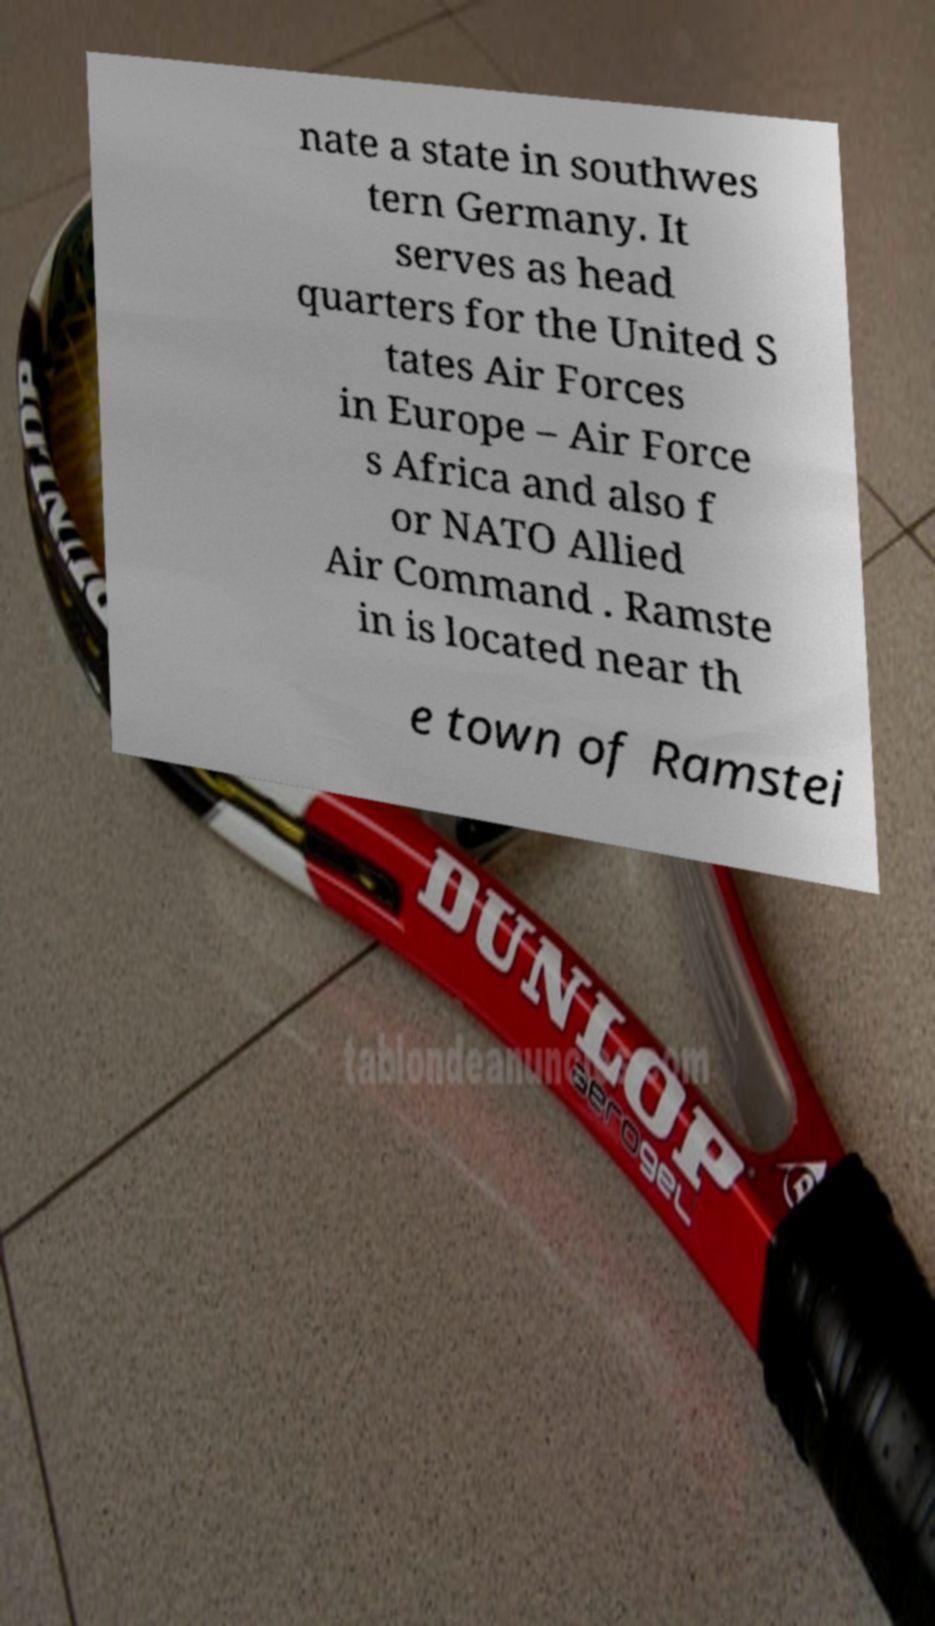Please read and relay the text visible in this image. What does it say? nate a state in southwes tern Germany. It serves as head quarters for the United S tates Air Forces in Europe – Air Force s Africa and also f or NATO Allied Air Command . Ramste in is located near th e town of Ramstei 